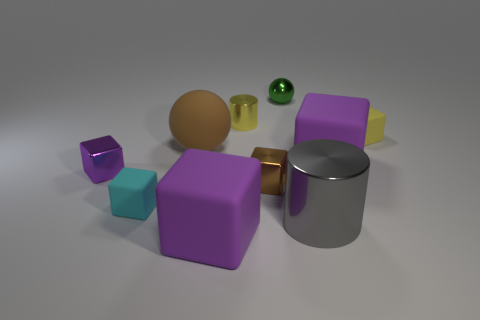What is the material of the object that is the same color as the tiny cylinder?
Offer a terse response. Rubber. There is a metal block to the right of the large matte sphere; what is its color?
Offer a terse response. Brown. Is the big ball the same color as the tiny metal ball?
Keep it short and to the point. No. How many metal blocks are in front of the large purple object that is on the left side of the tiny cylinder behind the tiny brown object?
Your answer should be very brief. 0. The brown rubber sphere is what size?
Keep it short and to the point. Large. There is a purple object that is the same size as the cyan cube; what material is it?
Offer a terse response. Metal. How many small cyan matte cubes are on the right side of the cyan matte block?
Provide a short and direct response. 0. Does the tiny yellow object that is behind the tiny yellow block have the same material as the big cube that is behind the cyan object?
Provide a short and direct response. No. What shape is the shiny object to the left of the cyan rubber thing that is on the left side of the yellow object in front of the small shiny cylinder?
Your response must be concise. Cube. What is the shape of the tiny cyan thing?
Your answer should be compact. Cube. 